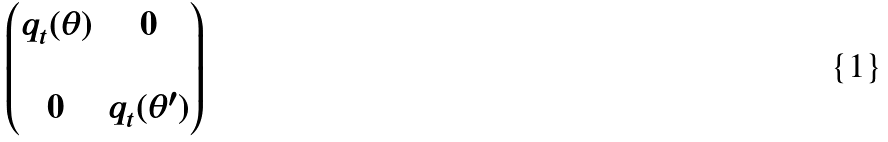<formula> <loc_0><loc_0><loc_500><loc_500>\begin{pmatrix} q _ { t } ( \theta ) & 0 \\ \\ 0 & q _ { t } ( \theta ^ { \prime } ) \end{pmatrix}</formula> 